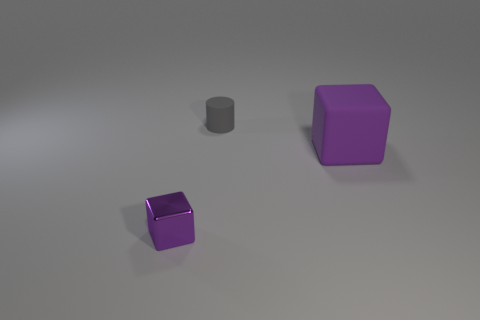The block that is to the left of the cube to the right of the rubber cylinder behind the small purple object is what color?
Keep it short and to the point. Purple. What number of other objects are the same size as the purple shiny block?
Ensure brevity in your answer.  1. Is there anything else that has the same shape as the small metallic thing?
Your response must be concise. Yes. There is another thing that is the same shape as the purple rubber thing; what color is it?
Offer a terse response. Purple. What color is the cube that is made of the same material as the tiny gray cylinder?
Your response must be concise. Purple. Are there an equal number of tiny gray objects in front of the small rubber object and large purple matte objects?
Make the answer very short. No. There is a rubber thing that is behind the matte block; is its size the same as the tiny shiny thing?
Offer a very short reply. Yes. What is the color of the cylinder that is the same size as the metallic thing?
Give a very brief answer. Gray. Is there a tiny purple cube that is on the right side of the rubber cylinder that is to the right of the purple object to the left of the gray object?
Offer a terse response. No. What is the material of the small object on the left side of the cylinder?
Ensure brevity in your answer.  Metal. 